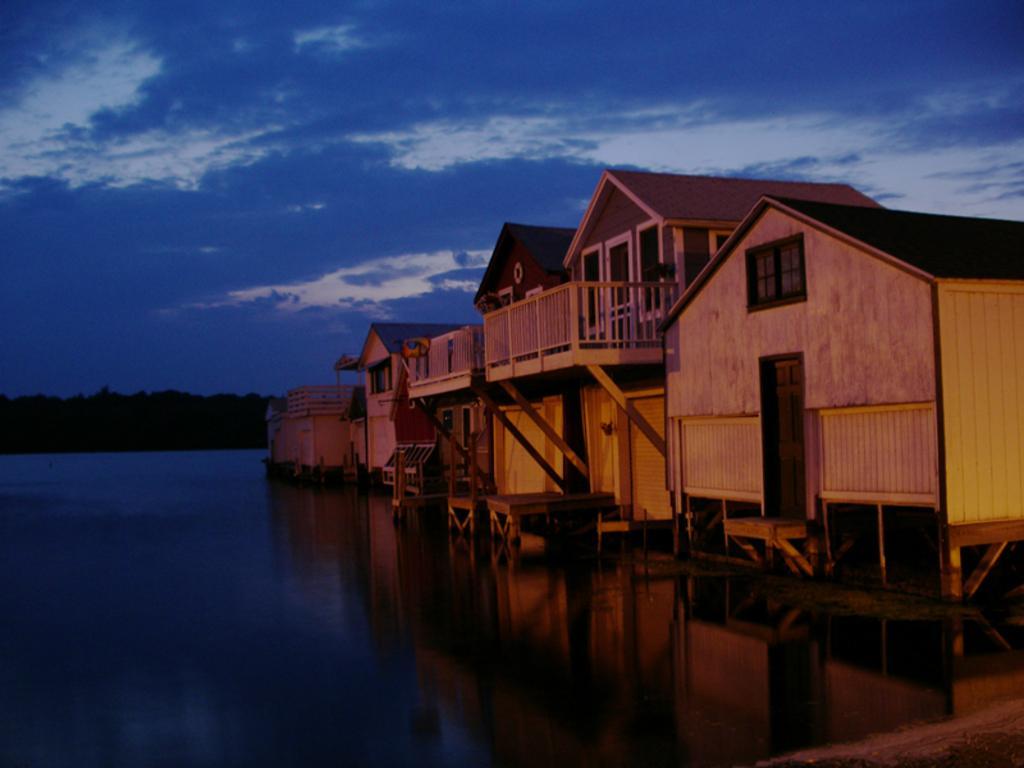Could you give a brief overview of what you see in this image? As we can see in the image there are houses and water. In the background there are trees. On the top there sky and clouds. 